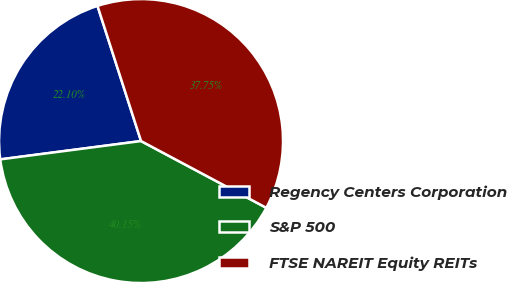Convert chart to OTSL. <chart><loc_0><loc_0><loc_500><loc_500><pie_chart><fcel>Regency Centers Corporation<fcel>S&P 500<fcel>FTSE NAREIT Equity REITs<nl><fcel>22.1%<fcel>40.15%<fcel>37.75%<nl></chart> 